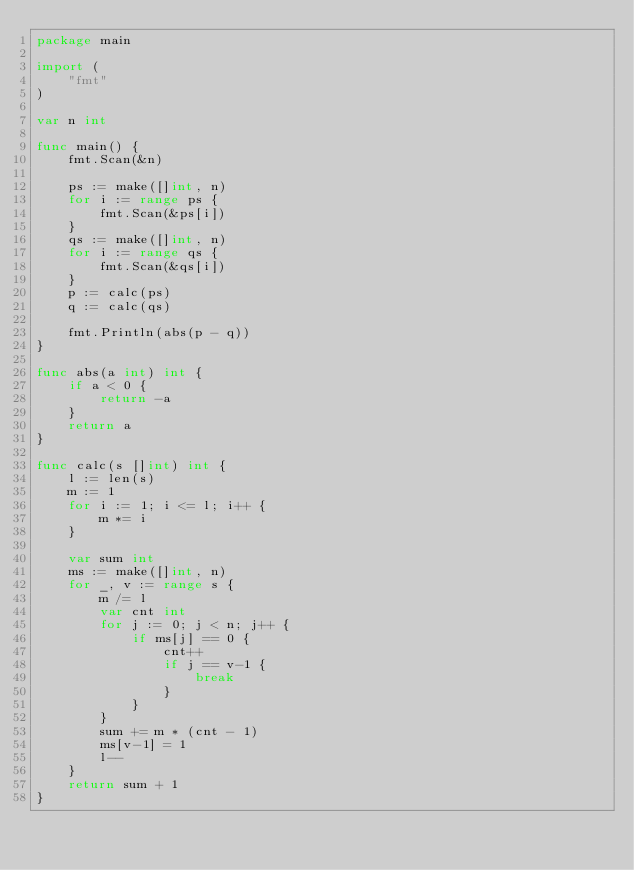Convert code to text. <code><loc_0><loc_0><loc_500><loc_500><_Go_>package main

import (
	"fmt"
)

var n int

func main() {
	fmt.Scan(&n)

	ps := make([]int, n)
	for i := range ps {
		fmt.Scan(&ps[i])
	}
	qs := make([]int, n)
	for i := range qs {
		fmt.Scan(&qs[i])
	}
	p := calc(ps)
	q := calc(qs)

	fmt.Println(abs(p - q))
}

func abs(a int) int {
	if a < 0 {
		return -a
	}
	return a
}

func calc(s []int) int {
	l := len(s)
	m := 1
	for i := 1; i <= l; i++ {
		m *= i
	}

	var sum int
	ms := make([]int, n)
	for _, v := range s {
		m /= l
		var cnt int
		for j := 0; j < n; j++ {
			if ms[j] == 0 {
				cnt++
				if j == v-1 {
					break
				}
			}
		}
		sum += m * (cnt - 1)
		ms[v-1] = 1
		l--
	}
	return sum + 1
}
</code> 